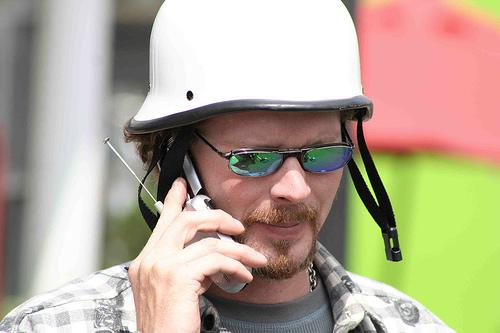Question: what is the man doing?
Choices:
A. Sitting.
B. Eating.
C. Talking on phone.
D. Listening to the music.
Answer with the letter. Answer: C Question: what isthe man wearing on is head?
Choices:
A. Helmet.
B. Hat.
C. Bandanna.
D. Sunglasses.
Answer with the letter. Answer: A Question: what does the man have on his face?
Choices:
A. Beard.
B. Mustache.
C. Sunglasses.
D. Birth mark.
Answer with the letter. Answer: C Question: what color t-shirt is the man wearing?
Choices:
A. Black.
B. Grey.
C. White.
D. Red.
Answer with the letter. Answer: B Question: what color straps are on the helmet?
Choices:
A. Black.
B. Brown.
C. Orange.
D. Yellow.
Answer with the letter. Answer: A 